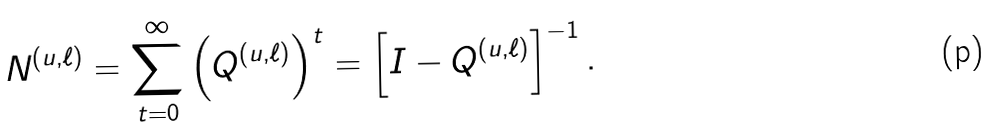<formula> <loc_0><loc_0><loc_500><loc_500>N ^ { ( u , \ell ) } = \sum _ { t = 0 } ^ { \infty } \left ( Q ^ { ( u , \ell ) } \right ) ^ { t } = \left [ I - Q ^ { ( u , \ell ) } \right ] ^ { - 1 } .</formula> 